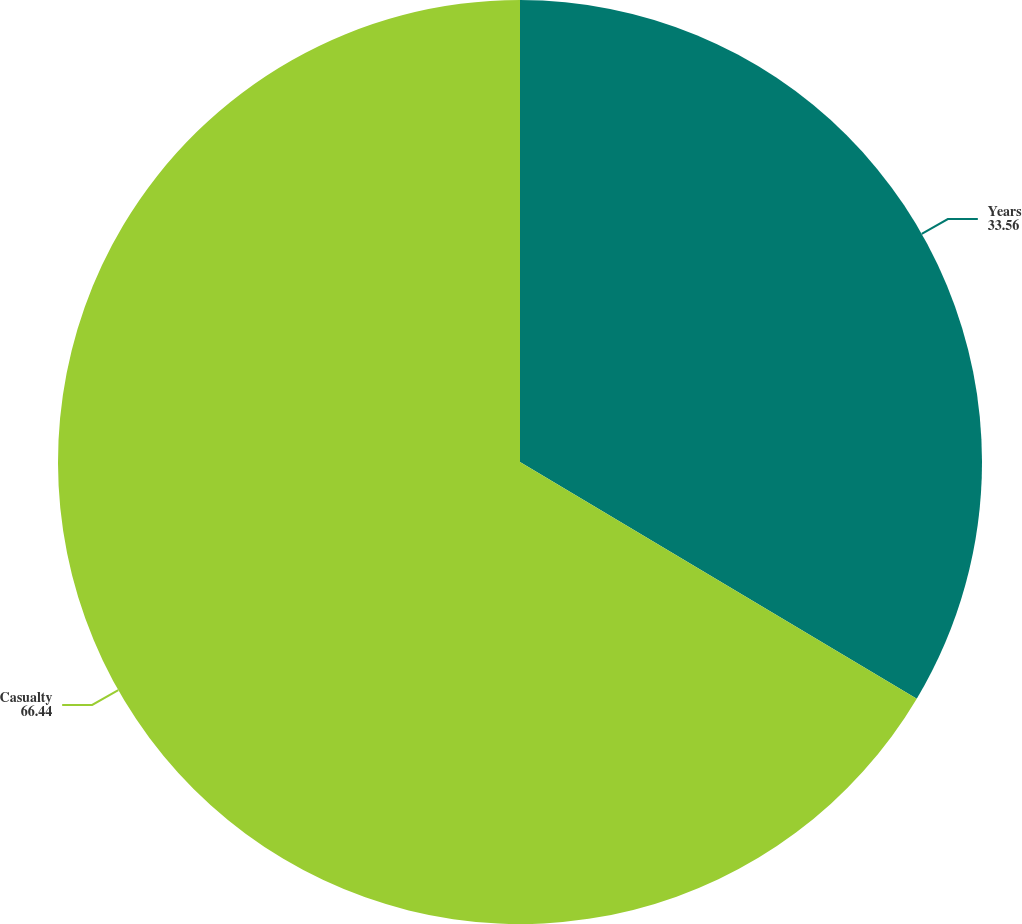Convert chart. <chart><loc_0><loc_0><loc_500><loc_500><pie_chart><fcel>Years<fcel>Casualty<nl><fcel>33.56%<fcel>66.44%<nl></chart> 